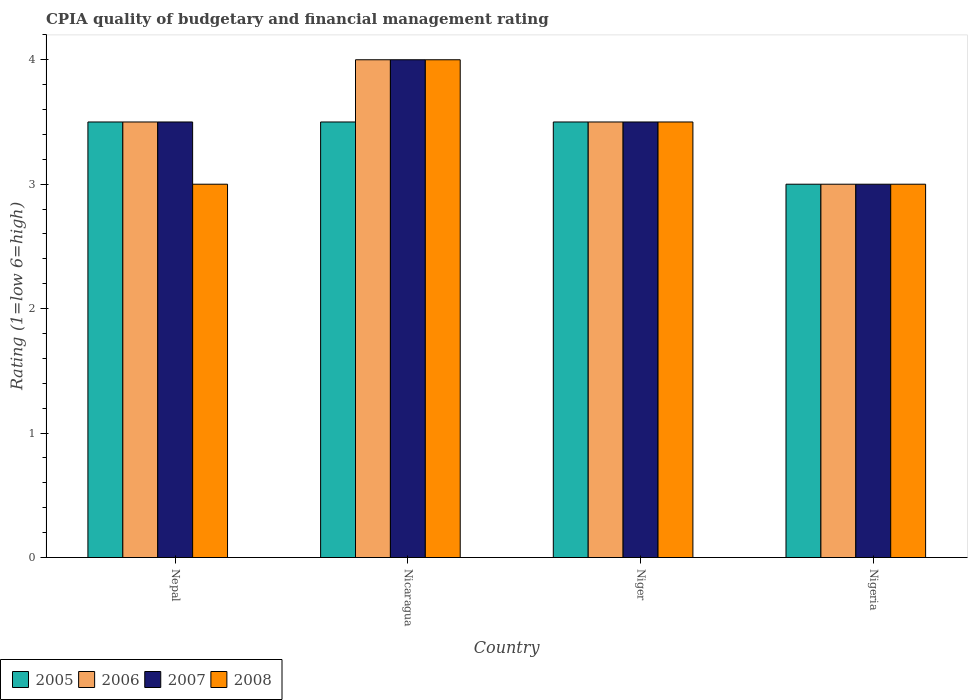How many groups of bars are there?
Provide a succinct answer. 4. How many bars are there on the 3rd tick from the right?
Give a very brief answer. 4. What is the label of the 2nd group of bars from the left?
Your response must be concise. Nicaragua. In how many cases, is the number of bars for a given country not equal to the number of legend labels?
Make the answer very short. 0. What is the CPIA rating in 2008 in Niger?
Keep it short and to the point. 3.5. Across all countries, what is the minimum CPIA rating in 2007?
Keep it short and to the point. 3. In which country was the CPIA rating in 2006 maximum?
Make the answer very short. Nicaragua. In which country was the CPIA rating in 2008 minimum?
Offer a very short reply. Nepal. What is the average CPIA rating in 2008 per country?
Ensure brevity in your answer.  3.38. In how many countries, is the CPIA rating in 2007 greater than 2?
Offer a very short reply. 4. What is the difference between the highest and the second highest CPIA rating in 2008?
Your answer should be very brief. -0.5. In how many countries, is the CPIA rating in 2006 greater than the average CPIA rating in 2006 taken over all countries?
Keep it short and to the point. 1. Is it the case that in every country, the sum of the CPIA rating in 2005 and CPIA rating in 2008 is greater than the sum of CPIA rating in 2007 and CPIA rating in 2006?
Your answer should be compact. No. What does the 3rd bar from the right in Niger represents?
Your answer should be very brief. 2006. Is it the case that in every country, the sum of the CPIA rating in 2007 and CPIA rating in 2005 is greater than the CPIA rating in 2008?
Your answer should be compact. Yes. What is the difference between two consecutive major ticks on the Y-axis?
Offer a very short reply. 1. Does the graph contain any zero values?
Ensure brevity in your answer.  No. Does the graph contain grids?
Your answer should be very brief. No. Where does the legend appear in the graph?
Your answer should be compact. Bottom left. How many legend labels are there?
Provide a succinct answer. 4. How are the legend labels stacked?
Your response must be concise. Horizontal. What is the title of the graph?
Keep it short and to the point. CPIA quality of budgetary and financial management rating. What is the Rating (1=low 6=high) in 2005 in Nepal?
Offer a very short reply. 3.5. What is the Rating (1=low 6=high) of 2006 in Nepal?
Ensure brevity in your answer.  3.5. What is the Rating (1=low 6=high) of 2008 in Nepal?
Offer a very short reply. 3. What is the Rating (1=low 6=high) in 2007 in Nicaragua?
Your answer should be compact. 4. What is the Rating (1=low 6=high) in 2008 in Nicaragua?
Provide a short and direct response. 4. What is the Rating (1=low 6=high) of 2005 in Niger?
Give a very brief answer. 3.5. What is the Rating (1=low 6=high) in 2006 in Niger?
Offer a very short reply. 3.5. What is the Rating (1=low 6=high) of 2007 in Nigeria?
Your answer should be compact. 3. What is the Rating (1=low 6=high) in 2008 in Nigeria?
Provide a short and direct response. 3. Across all countries, what is the maximum Rating (1=low 6=high) of 2005?
Make the answer very short. 3.5. Across all countries, what is the maximum Rating (1=low 6=high) in 2006?
Provide a succinct answer. 4. Across all countries, what is the maximum Rating (1=low 6=high) of 2008?
Offer a very short reply. 4. Across all countries, what is the minimum Rating (1=low 6=high) in 2007?
Provide a short and direct response. 3. Across all countries, what is the minimum Rating (1=low 6=high) of 2008?
Make the answer very short. 3. What is the total Rating (1=low 6=high) of 2006 in the graph?
Provide a succinct answer. 14. What is the total Rating (1=low 6=high) of 2007 in the graph?
Your response must be concise. 14. What is the difference between the Rating (1=low 6=high) of 2005 in Nepal and that in Nicaragua?
Offer a very short reply. 0. What is the difference between the Rating (1=low 6=high) of 2006 in Nepal and that in Nicaragua?
Make the answer very short. -0.5. What is the difference between the Rating (1=low 6=high) of 2007 in Nepal and that in Nicaragua?
Offer a terse response. -0.5. What is the difference between the Rating (1=low 6=high) of 2005 in Nepal and that in Niger?
Offer a very short reply. 0. What is the difference between the Rating (1=low 6=high) of 2005 in Nepal and that in Nigeria?
Provide a succinct answer. 0.5. What is the difference between the Rating (1=low 6=high) of 2007 in Nepal and that in Nigeria?
Your answer should be very brief. 0.5. What is the difference between the Rating (1=low 6=high) in 2005 in Nicaragua and that in Niger?
Your answer should be compact. 0. What is the difference between the Rating (1=low 6=high) in 2006 in Nicaragua and that in Niger?
Provide a succinct answer. 0.5. What is the difference between the Rating (1=low 6=high) in 2008 in Nicaragua and that in Niger?
Your answer should be compact. 0.5. What is the difference between the Rating (1=low 6=high) of 2007 in Nicaragua and that in Nigeria?
Your answer should be very brief. 1. What is the difference between the Rating (1=low 6=high) of 2005 in Niger and that in Nigeria?
Ensure brevity in your answer.  0.5. What is the difference between the Rating (1=low 6=high) of 2006 in Niger and that in Nigeria?
Offer a very short reply. 0.5. What is the difference between the Rating (1=low 6=high) of 2008 in Niger and that in Nigeria?
Keep it short and to the point. 0.5. What is the difference between the Rating (1=low 6=high) of 2005 in Nepal and the Rating (1=low 6=high) of 2006 in Nicaragua?
Your response must be concise. -0.5. What is the difference between the Rating (1=low 6=high) of 2006 in Nepal and the Rating (1=low 6=high) of 2008 in Nicaragua?
Offer a terse response. -0.5. What is the difference between the Rating (1=low 6=high) of 2006 in Nepal and the Rating (1=low 6=high) of 2008 in Niger?
Make the answer very short. 0. What is the difference between the Rating (1=low 6=high) of 2007 in Nepal and the Rating (1=low 6=high) of 2008 in Niger?
Offer a terse response. 0. What is the difference between the Rating (1=low 6=high) of 2005 in Nepal and the Rating (1=low 6=high) of 2007 in Nigeria?
Keep it short and to the point. 0.5. What is the difference between the Rating (1=low 6=high) of 2005 in Nepal and the Rating (1=low 6=high) of 2008 in Nigeria?
Your answer should be very brief. 0.5. What is the difference between the Rating (1=low 6=high) in 2006 in Nepal and the Rating (1=low 6=high) in 2007 in Nigeria?
Your response must be concise. 0.5. What is the difference between the Rating (1=low 6=high) in 2006 in Nepal and the Rating (1=low 6=high) in 2008 in Nigeria?
Give a very brief answer. 0.5. What is the difference between the Rating (1=low 6=high) of 2005 in Nicaragua and the Rating (1=low 6=high) of 2006 in Niger?
Your answer should be compact. 0. What is the difference between the Rating (1=low 6=high) in 2005 in Nicaragua and the Rating (1=low 6=high) in 2007 in Niger?
Your answer should be very brief. 0. What is the difference between the Rating (1=low 6=high) of 2005 in Nicaragua and the Rating (1=low 6=high) of 2008 in Niger?
Provide a succinct answer. 0. What is the difference between the Rating (1=low 6=high) in 2006 in Nicaragua and the Rating (1=low 6=high) in 2007 in Niger?
Ensure brevity in your answer.  0.5. What is the difference between the Rating (1=low 6=high) of 2005 in Niger and the Rating (1=low 6=high) of 2006 in Nigeria?
Offer a very short reply. 0.5. What is the difference between the Rating (1=low 6=high) of 2005 in Niger and the Rating (1=low 6=high) of 2007 in Nigeria?
Keep it short and to the point. 0.5. What is the difference between the Rating (1=low 6=high) of 2005 in Niger and the Rating (1=low 6=high) of 2008 in Nigeria?
Give a very brief answer. 0.5. What is the difference between the Rating (1=low 6=high) of 2006 in Niger and the Rating (1=low 6=high) of 2007 in Nigeria?
Provide a short and direct response. 0.5. What is the difference between the Rating (1=low 6=high) of 2007 in Niger and the Rating (1=low 6=high) of 2008 in Nigeria?
Offer a very short reply. 0.5. What is the average Rating (1=low 6=high) in 2005 per country?
Your answer should be compact. 3.38. What is the average Rating (1=low 6=high) in 2007 per country?
Provide a short and direct response. 3.5. What is the average Rating (1=low 6=high) of 2008 per country?
Provide a succinct answer. 3.38. What is the difference between the Rating (1=low 6=high) in 2007 and Rating (1=low 6=high) in 2008 in Nepal?
Your answer should be compact. 0.5. What is the difference between the Rating (1=low 6=high) in 2005 and Rating (1=low 6=high) in 2008 in Nicaragua?
Offer a terse response. -0.5. What is the difference between the Rating (1=low 6=high) in 2006 and Rating (1=low 6=high) in 2007 in Nicaragua?
Offer a terse response. 0. What is the difference between the Rating (1=low 6=high) in 2005 and Rating (1=low 6=high) in 2007 in Niger?
Make the answer very short. 0. What is the difference between the Rating (1=low 6=high) in 2006 and Rating (1=low 6=high) in 2007 in Niger?
Make the answer very short. 0. What is the difference between the Rating (1=low 6=high) in 2005 and Rating (1=low 6=high) in 2007 in Nigeria?
Your answer should be compact. 0. What is the difference between the Rating (1=low 6=high) in 2005 and Rating (1=low 6=high) in 2008 in Nigeria?
Give a very brief answer. 0. What is the difference between the Rating (1=low 6=high) in 2006 and Rating (1=low 6=high) in 2008 in Nigeria?
Ensure brevity in your answer.  0. What is the difference between the Rating (1=low 6=high) of 2007 and Rating (1=low 6=high) of 2008 in Nigeria?
Keep it short and to the point. 0. What is the ratio of the Rating (1=low 6=high) of 2005 in Nepal to that in Nicaragua?
Your answer should be compact. 1. What is the ratio of the Rating (1=low 6=high) of 2006 in Nepal to that in Nicaragua?
Keep it short and to the point. 0.88. What is the ratio of the Rating (1=low 6=high) in 2006 in Nepal to that in Niger?
Give a very brief answer. 1. What is the ratio of the Rating (1=low 6=high) of 2008 in Nepal to that in Nigeria?
Provide a short and direct response. 1. What is the ratio of the Rating (1=low 6=high) of 2006 in Nicaragua to that in Niger?
Ensure brevity in your answer.  1.14. What is the ratio of the Rating (1=low 6=high) of 2007 in Nicaragua to that in Niger?
Your answer should be very brief. 1.14. What is the ratio of the Rating (1=low 6=high) of 2005 in Nicaragua to that in Nigeria?
Offer a very short reply. 1.17. What is the ratio of the Rating (1=low 6=high) in 2006 in Nicaragua to that in Nigeria?
Give a very brief answer. 1.33. What is the ratio of the Rating (1=low 6=high) of 2007 in Nicaragua to that in Nigeria?
Provide a short and direct response. 1.33. What is the ratio of the Rating (1=low 6=high) in 2008 in Nicaragua to that in Nigeria?
Provide a succinct answer. 1.33. What is the ratio of the Rating (1=low 6=high) of 2005 in Niger to that in Nigeria?
Ensure brevity in your answer.  1.17. What is the ratio of the Rating (1=low 6=high) in 2007 in Niger to that in Nigeria?
Offer a very short reply. 1.17. What is the difference between the highest and the second highest Rating (1=low 6=high) in 2005?
Provide a succinct answer. 0. What is the difference between the highest and the second highest Rating (1=low 6=high) in 2007?
Give a very brief answer. 0.5. What is the difference between the highest and the second highest Rating (1=low 6=high) of 2008?
Offer a terse response. 0.5. What is the difference between the highest and the lowest Rating (1=low 6=high) in 2006?
Your response must be concise. 1. What is the difference between the highest and the lowest Rating (1=low 6=high) in 2008?
Ensure brevity in your answer.  1. 